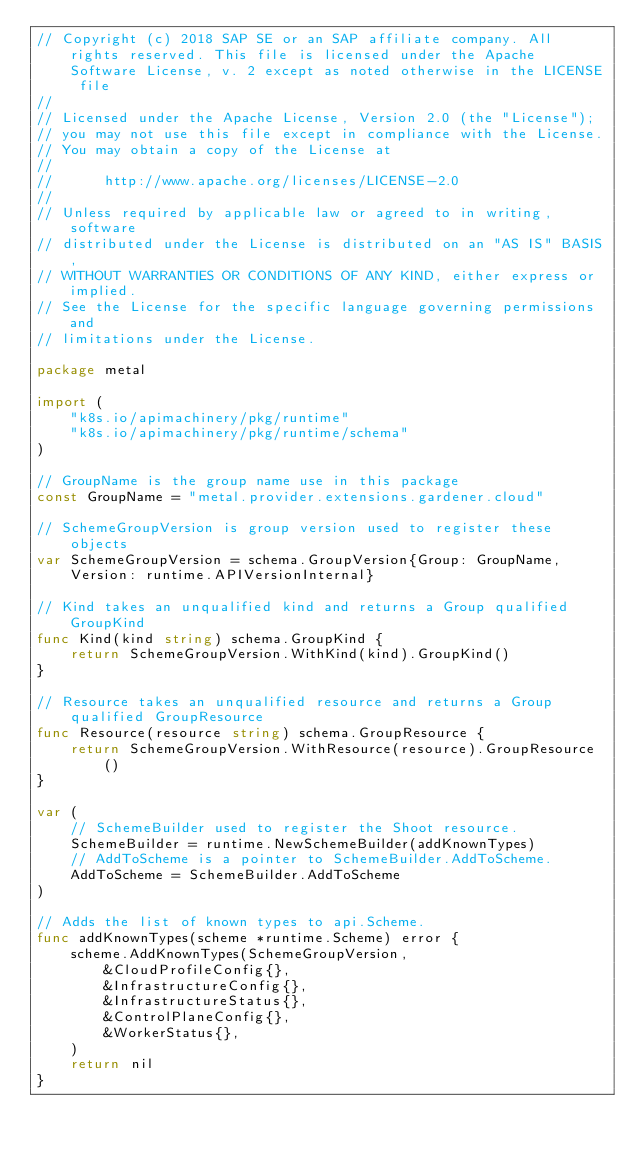<code> <loc_0><loc_0><loc_500><loc_500><_Go_>// Copyright (c) 2018 SAP SE or an SAP affiliate company. All rights reserved. This file is licensed under the Apache Software License, v. 2 except as noted otherwise in the LICENSE file
//
// Licensed under the Apache License, Version 2.0 (the "License");
// you may not use this file except in compliance with the License.
// You may obtain a copy of the License at
//
//      http://www.apache.org/licenses/LICENSE-2.0
//
// Unless required by applicable law or agreed to in writing, software
// distributed under the License is distributed on an "AS IS" BASIS,
// WITHOUT WARRANTIES OR CONDITIONS OF ANY KIND, either express or implied.
// See the License for the specific language governing permissions and
// limitations under the License.

package metal

import (
	"k8s.io/apimachinery/pkg/runtime"
	"k8s.io/apimachinery/pkg/runtime/schema"
)

// GroupName is the group name use in this package
const GroupName = "metal.provider.extensions.gardener.cloud"

// SchemeGroupVersion is group version used to register these objects
var SchemeGroupVersion = schema.GroupVersion{Group: GroupName, Version: runtime.APIVersionInternal}

// Kind takes an unqualified kind and returns a Group qualified GroupKind
func Kind(kind string) schema.GroupKind {
	return SchemeGroupVersion.WithKind(kind).GroupKind()
}

// Resource takes an unqualified resource and returns a Group qualified GroupResource
func Resource(resource string) schema.GroupResource {
	return SchemeGroupVersion.WithResource(resource).GroupResource()
}

var (
	// SchemeBuilder used to register the Shoot resource.
	SchemeBuilder = runtime.NewSchemeBuilder(addKnownTypes)
	// AddToScheme is a pointer to SchemeBuilder.AddToScheme.
	AddToScheme = SchemeBuilder.AddToScheme
)

// Adds the list of known types to api.Scheme.
func addKnownTypes(scheme *runtime.Scheme) error {
	scheme.AddKnownTypes(SchemeGroupVersion,
		&CloudProfileConfig{},
		&InfrastructureConfig{},
		&InfrastructureStatus{},
		&ControlPlaneConfig{},
		&WorkerStatus{},
	)
	return nil
}
</code> 